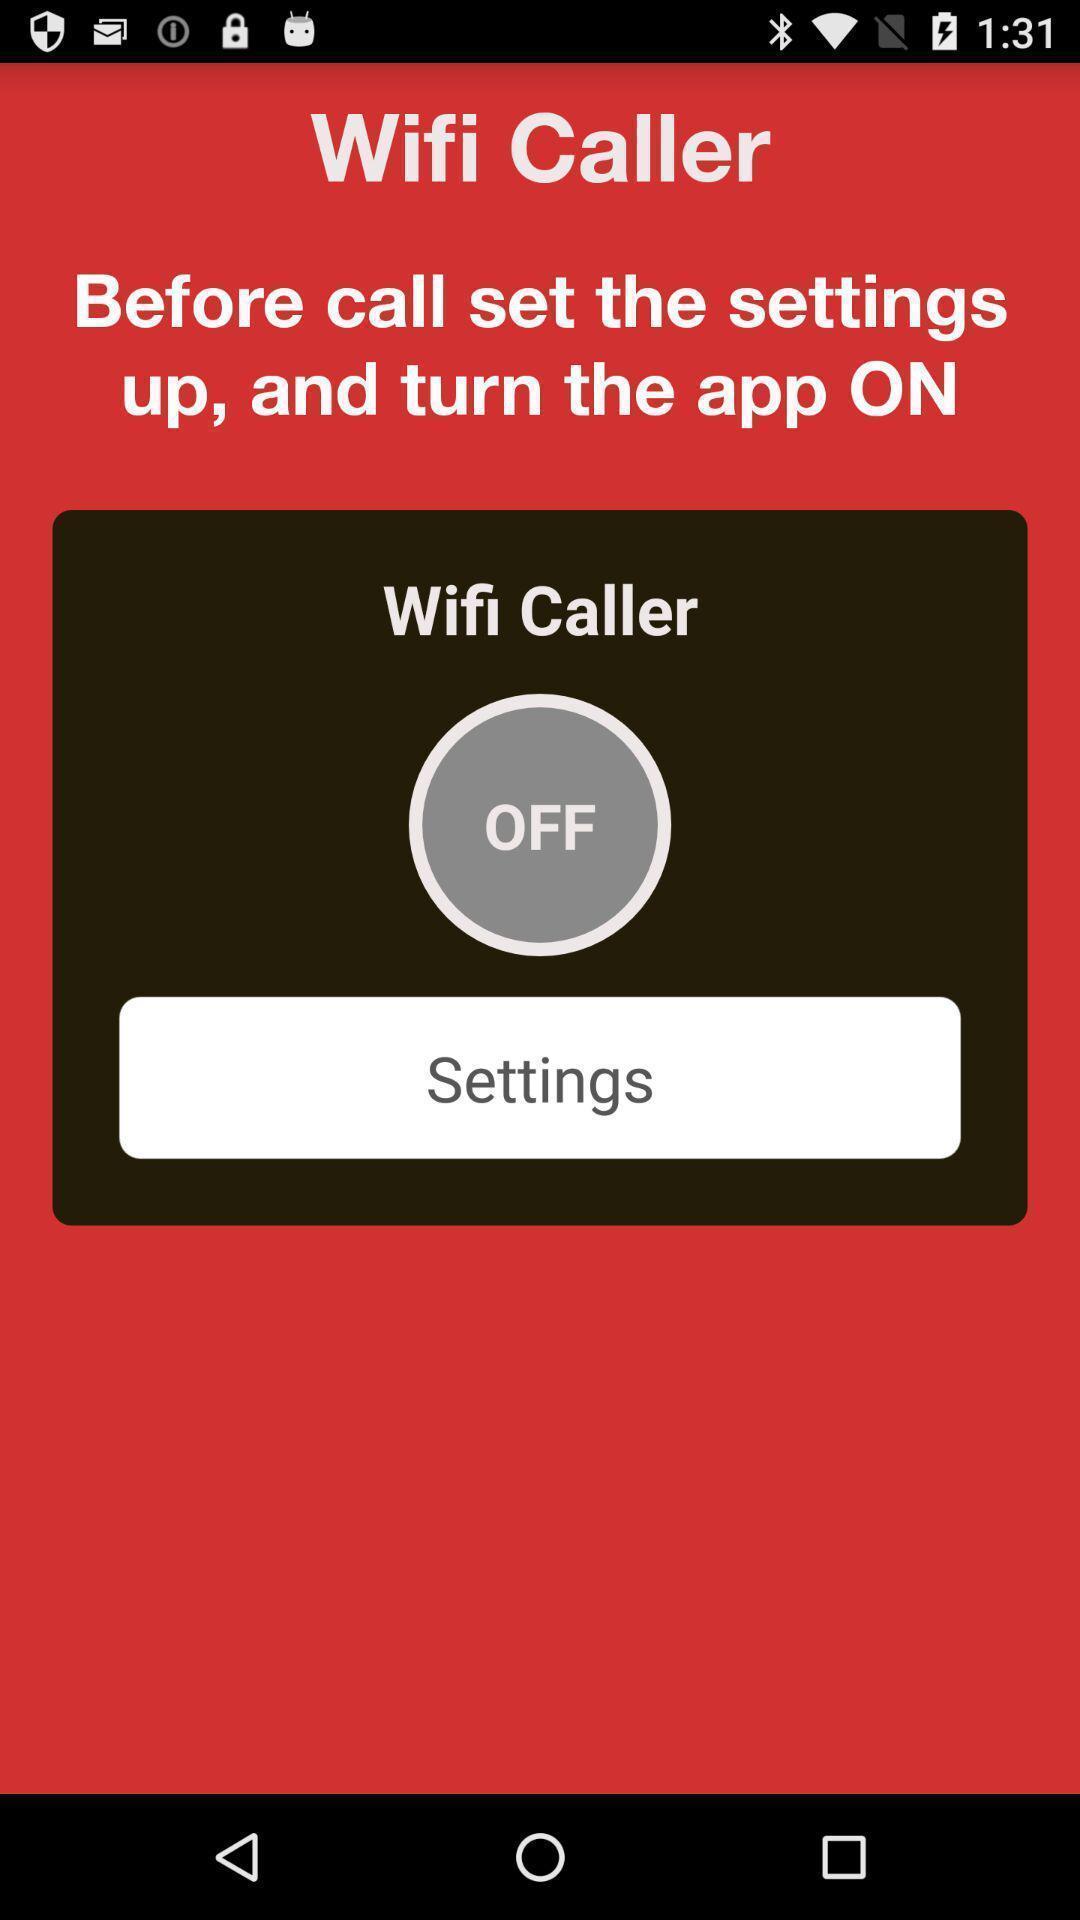Explain what's happening in this screen capture. Page showing settings option. 